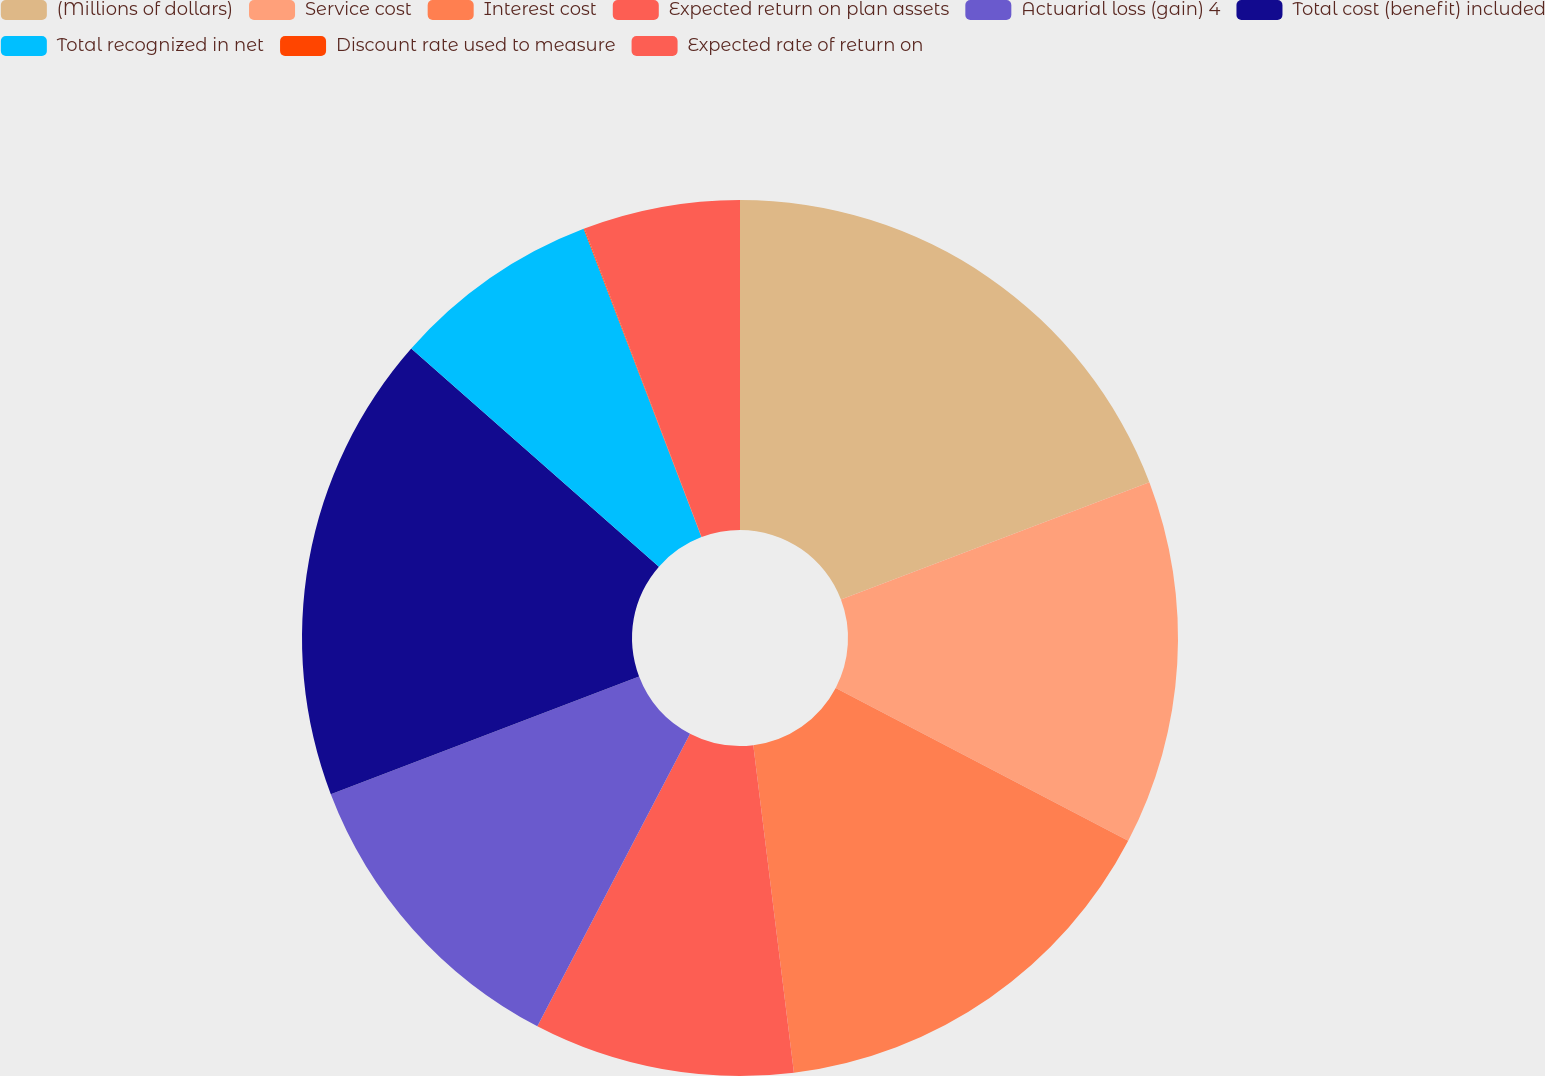<chart> <loc_0><loc_0><loc_500><loc_500><pie_chart><fcel>(Millions of dollars)<fcel>Service cost<fcel>Interest cost<fcel>Expected return on plan assets<fcel>Actuarial loss (gain) 4<fcel>Total cost (benefit) included<fcel>Total recognized in net<fcel>Discount rate used to measure<fcel>Expected rate of return on<nl><fcel>19.21%<fcel>13.45%<fcel>15.37%<fcel>9.62%<fcel>11.54%<fcel>17.29%<fcel>7.7%<fcel>0.03%<fcel>5.78%<nl></chart> 